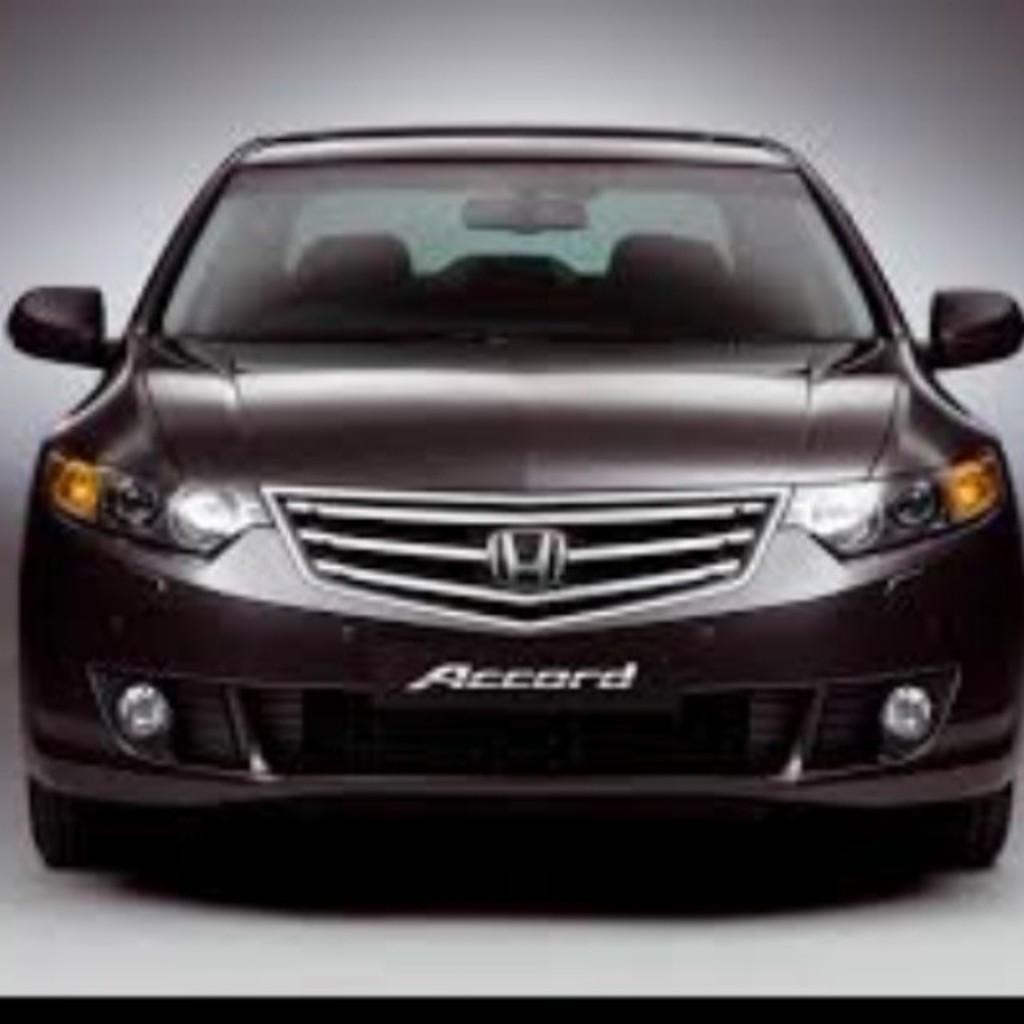Describe this image in one or two sentences. In this image I can see a car with some text. 